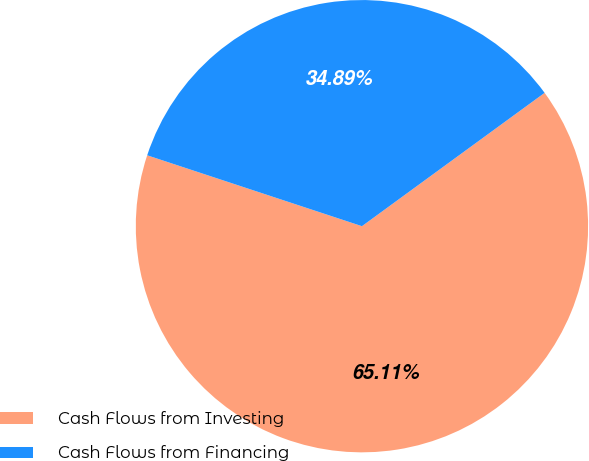Convert chart. <chart><loc_0><loc_0><loc_500><loc_500><pie_chart><fcel>Cash Flows from Investing<fcel>Cash Flows from Financing<nl><fcel>65.11%<fcel>34.89%<nl></chart> 